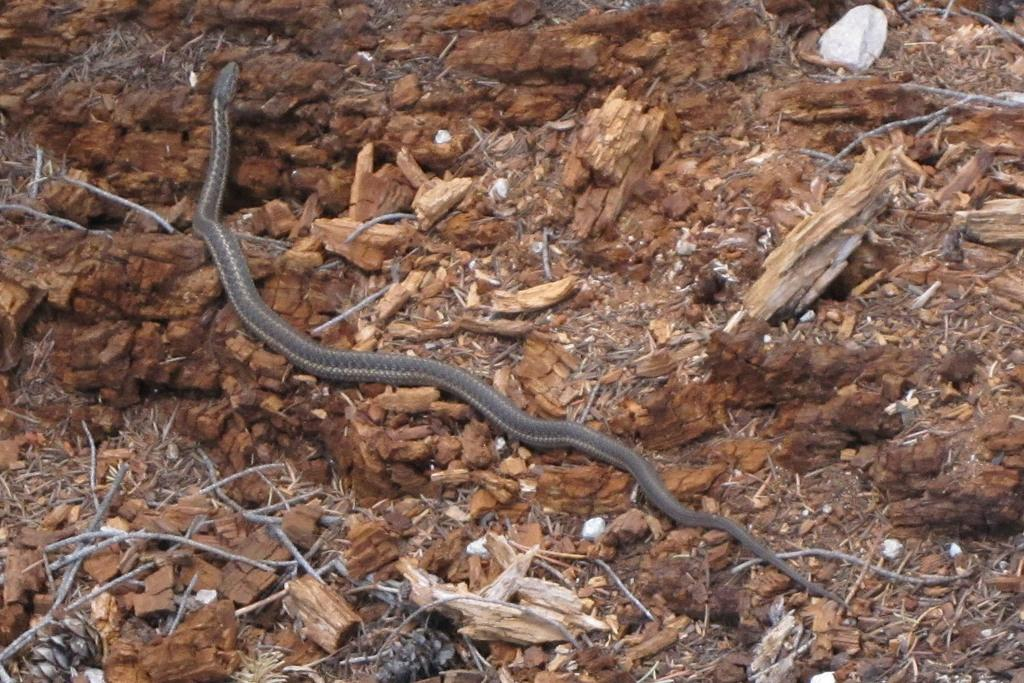What type of animal can be seen on the ground in the image? There is a snake on the ground in the image. What is the texture of the ground in the image? Dry grass is visible in the image. What other objects can be seen in the image? Wood sticks are present in the image. Can you determine the time of day when the image was taken? The image was likely taken during the day, as there is sufficient light to see the snake and the surrounding environment. What type of soup is being prepared in the image? There is no soup present in the image; it features a snake on the ground and dry grass. Can you tell me how many strings are attached to the snake in the image? There are no strings present in the image. 